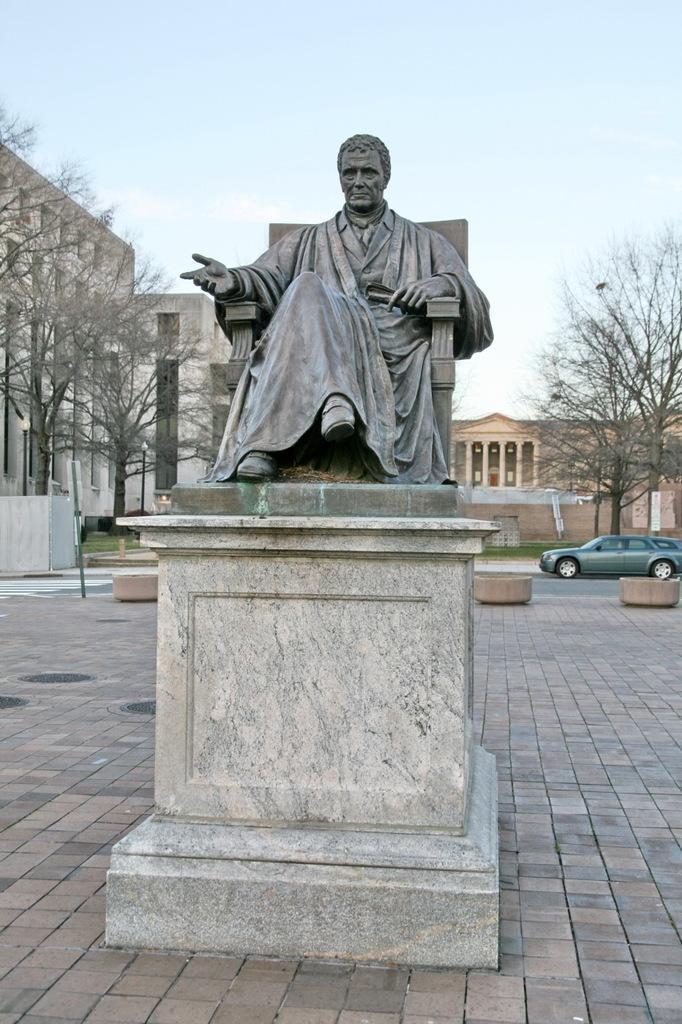Describe this image in one or two sentences. In this image in the center there is one statue and in the background there are some buildings, trees, vehicle, grass and at the bottom there is a walkway. 